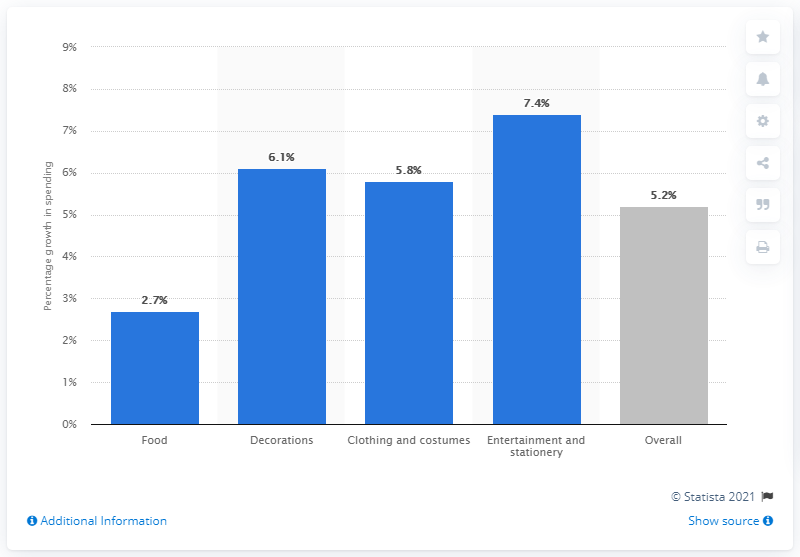Outline some significant characteristics in this image. According to statistics, the growth rate for entertainment and stationery is 7.4%. The expected growth in Halloween spending in the UK in 2014 is projected to be 5.2%. 